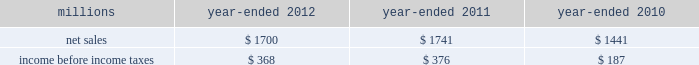74 2012 ppg annual report and form 10-k 25 .
Separation and merger transaction on january , 28 , 2013 , the company completed the previously announced separation of its commodity chemicals business and merger of its wholly-owned subsidiary , eagle spinco inc. , with a subsidiary of georgia gulf corporation in a tax efficient reverse morris trust transaction ( the 201ctransaction 201d ) .
Pursuant to the merger , eagle spinco , the entity holding ppg's former commodity chemicals business , is now a wholly-owned subsidiary of georgia gulf .
The closing of the merger followed the expiration of the related exchange offer and the satisfaction of certain other conditions .
The combined company formed by uniting georgia gulf with ppg's former commodity chemicals business is named axiall corporation ( 201caxiall 201d ) .
Ppg holds no ownership interest in axiall .
Ppg received the necessary ruling from the internal revenue service and as a result this transaction was generally tax free to ppg and its shareholders .
Under the terms of the exchange offer , 35249104 shares of eagle spinco common stock were available for distribution in exchange for shares of ppg common stock accepted in the offer .
Following the merger , each share of eagle spinco common stock automatically converted into the right to receive one share of axiall corporation common stock .
Accordingly , ppg shareholders who tendered their shares of ppg common stock as part of this offer received 3.2562 shares of axiall common stock for each share of ppg common stock accepted for exchange .
Ppg was able to accept the maximum of 10825227 shares of ppg common stock for exchange in the offer , and thereby , reduced its outstanding shares by approximately 7% ( 7 % ) .
Under the terms of the transaction , ppg received $ 900 million of cash and 35.2 million shares of axiall common stock ( market value of $ 1.8 billion on january 25 , 2013 ) which was distributed to ppg shareholders by the exchange offer as described above .
The cash consideration is subject to customary post-closing adjustment , including a working capital adjustment .
In the transaction , ppg transferred environmental remediation liabilities , defined benefit pension plan assets and liabilities and other post-employment benefit liabilities related to the commodity chemicals business to axiall .
Ppg will report a gain on the transaction reflecting the excess of the sum of the cash proceeds received and the cost ( closing stock price on january 25 , 2013 ) of the ppg shares tendered and accepted in the exchange for the 35.2 million shares of axiall common stock over the net book value of the net assets of ppg's former commodity chemicals business .
The transaction will also result in a net partial settlement loss associated with the spin out and termination of defined benefit pension liabilities and the transfer of other post-retirement benefit liabilities under the terms of the transaction .
During 2012 , the company incurred $ 21 million of pretax expense , primarily for professional services , related to the transaction .
Additional transaction-related expenses will be incurred in 2013 .
Ppg will report the results of its commodity chemicals business for january 2013 and a net gain on the transaction as results from discontinued operations when it reports its results for the quarter ending march 31 , 2013 .
In the ppg results for prior periods , presented for comparative purposes beginning with the first quarter 2013 , the results of its former commodity chemicals business will be reclassified from continuing operations and presented as the results from discontinued operations .
The net sales and income before income taxes of the commodity chemicals business that will be reclassified and reported as discontinued operations are presented in the table below for the years ended december 31 , 2012 , 2011 and 2010: .
Income before income taxes for the year ended december 31 , 2012 , 2011 and 2010 is $ 4 million lower , $ 6 million higher and $ 2 million lower , respectively , than segment earnings for the ppg commodity chemicals segment reported for these periods .
These differences are due to the inclusion of certain gains , losses and expenses associated with the chlor-alkali and derivatives business that were not reported in the ppg commodity chemicals segment earnings in accordance with the accounting guidance on segment reporting .
Table of contents notes to the consolidated financial statements .
What was the percentage change in net sales of the commodity chemicals business that will be reclassified and reported as discontinued operations from 2011 to 2012? 
Computations: ((1700 - 1741) / 1741)
Answer: -0.02355. 